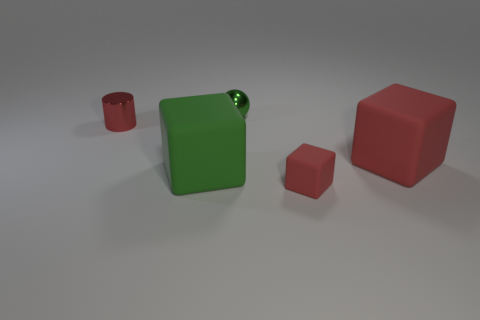There is a large cube that is the same color as the small metallic sphere; what is it made of?
Offer a very short reply. Rubber. How many small shiny spheres are there?
Provide a succinct answer. 1. Do the cube that is behind the green rubber object and the big green rubber object have the same size?
Your answer should be very brief. Yes. How many metallic objects are either red cubes or small red objects?
Give a very brief answer. 1. What number of tiny red things are to the left of the green object to the left of the green shiny thing?
Provide a succinct answer. 1. The rubber object that is behind the tiny matte block and on the left side of the large red rubber cube has what shape?
Offer a very short reply. Cube. The tiny thing on the left side of the tiny shiny thing behind the tiny shiny thing that is on the left side of the green shiny sphere is made of what material?
Your answer should be compact. Metal. There is a rubber object that is the same color as the ball; what is its size?
Offer a very short reply. Large. What is the material of the big green object?
Offer a terse response. Rubber. Is the tiny cylinder made of the same material as the green cube to the left of the small block?
Make the answer very short. No. 